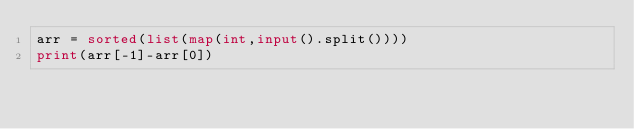<code> <loc_0><loc_0><loc_500><loc_500><_Python_>arr = sorted(list(map(int,input().split())))
print(arr[-1]-arr[0])
</code> 